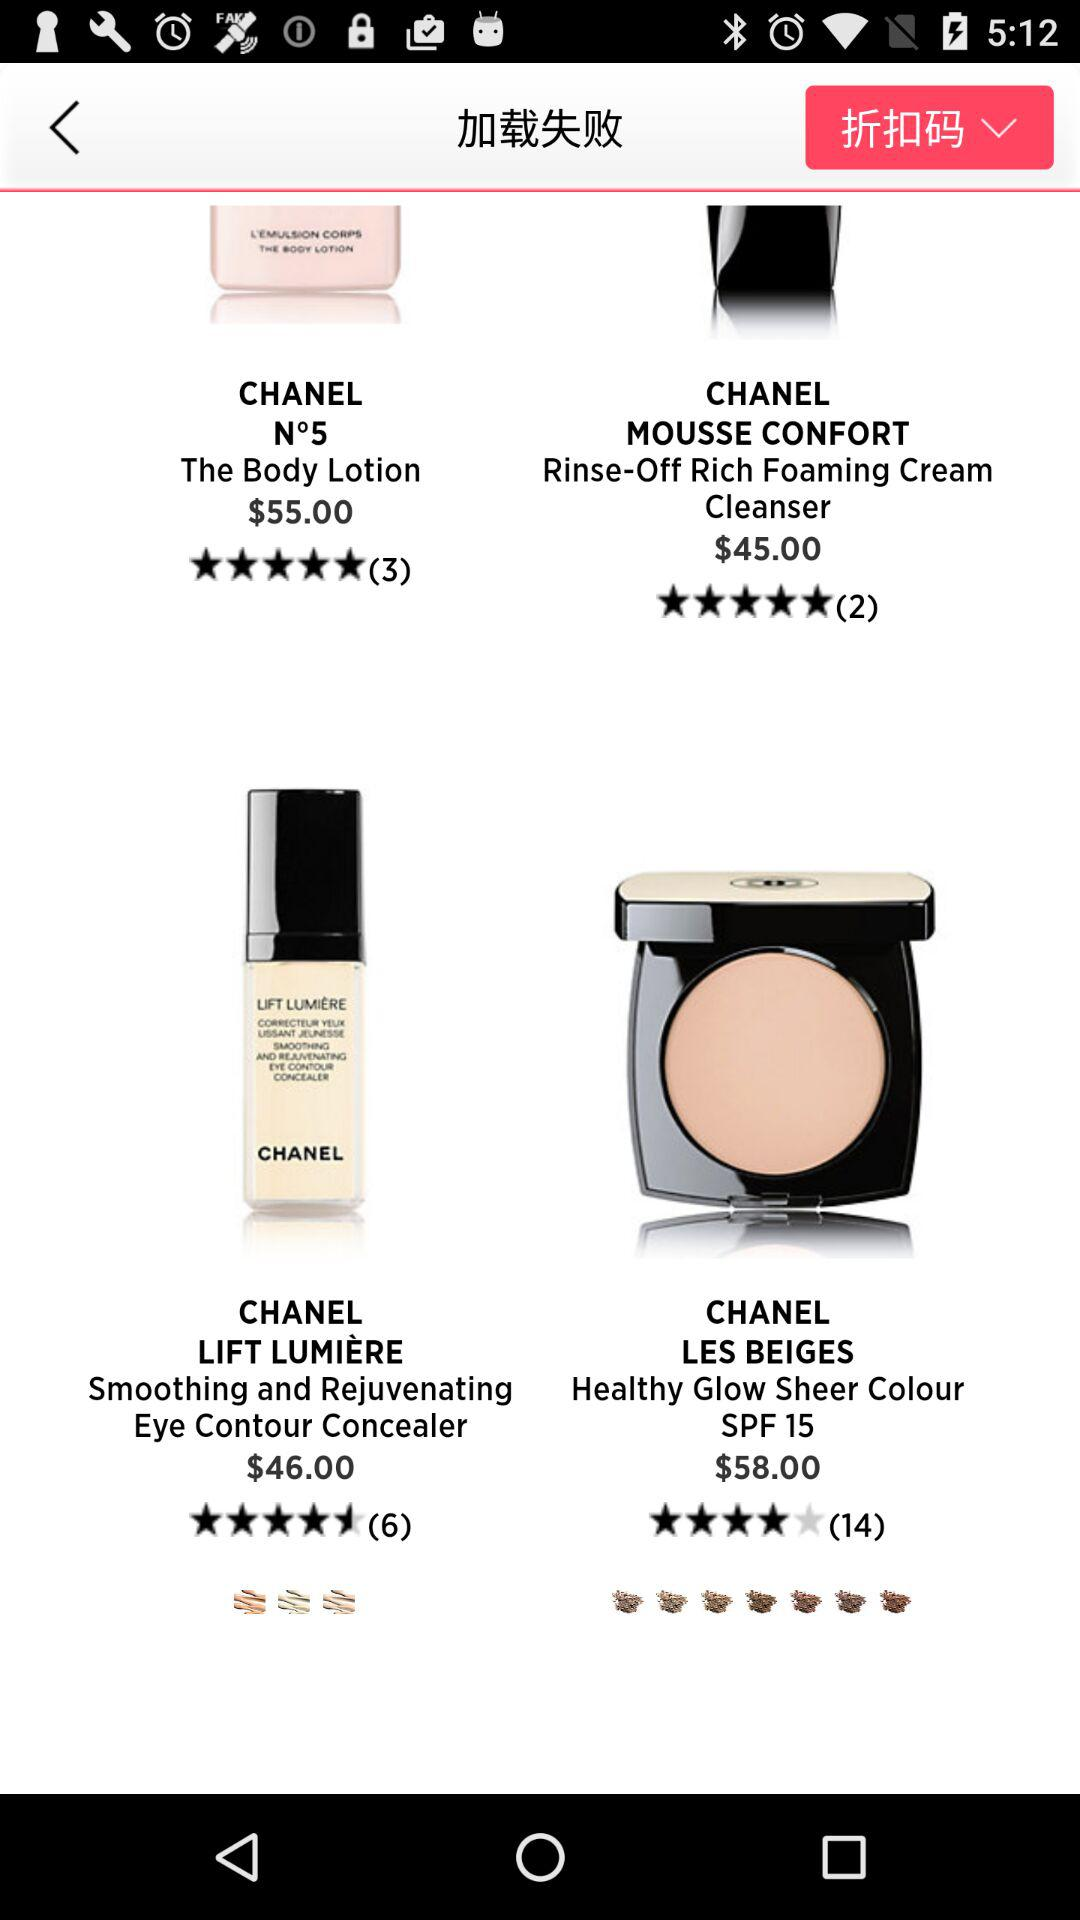What is the price of "Chanel Les Beiges"? The price is $58.00. 